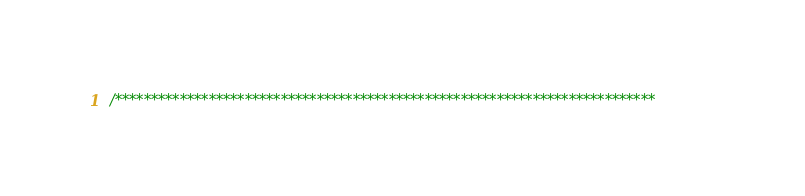<code> <loc_0><loc_0><loc_500><loc_500><_C_>/***************************************************************************</code> 